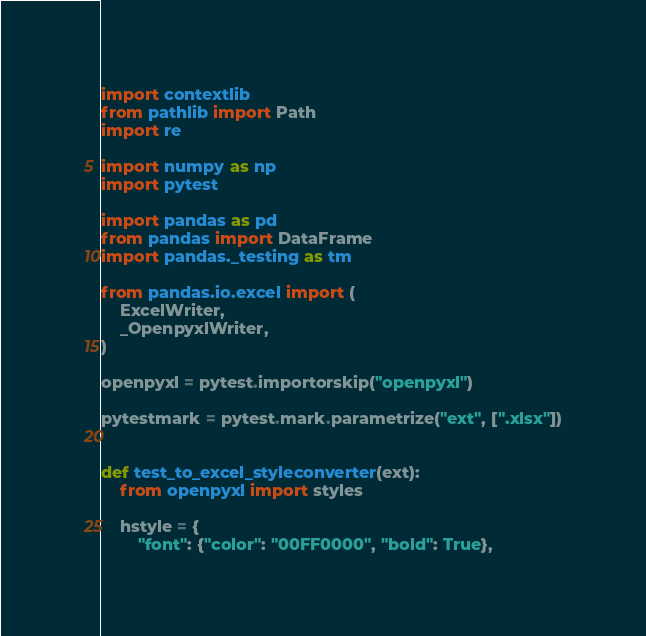<code> <loc_0><loc_0><loc_500><loc_500><_Python_>import contextlib
from pathlib import Path
import re

import numpy as np
import pytest

import pandas as pd
from pandas import DataFrame
import pandas._testing as tm

from pandas.io.excel import (
    ExcelWriter,
    _OpenpyxlWriter,
)

openpyxl = pytest.importorskip("openpyxl")

pytestmark = pytest.mark.parametrize("ext", [".xlsx"])


def test_to_excel_styleconverter(ext):
    from openpyxl import styles

    hstyle = {
        "font": {"color": "00FF0000", "bold": True},</code> 